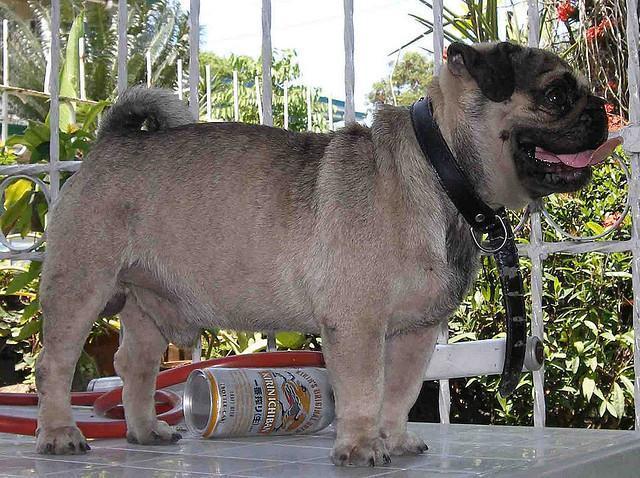How many people in the image are sitting?
Give a very brief answer. 0. 